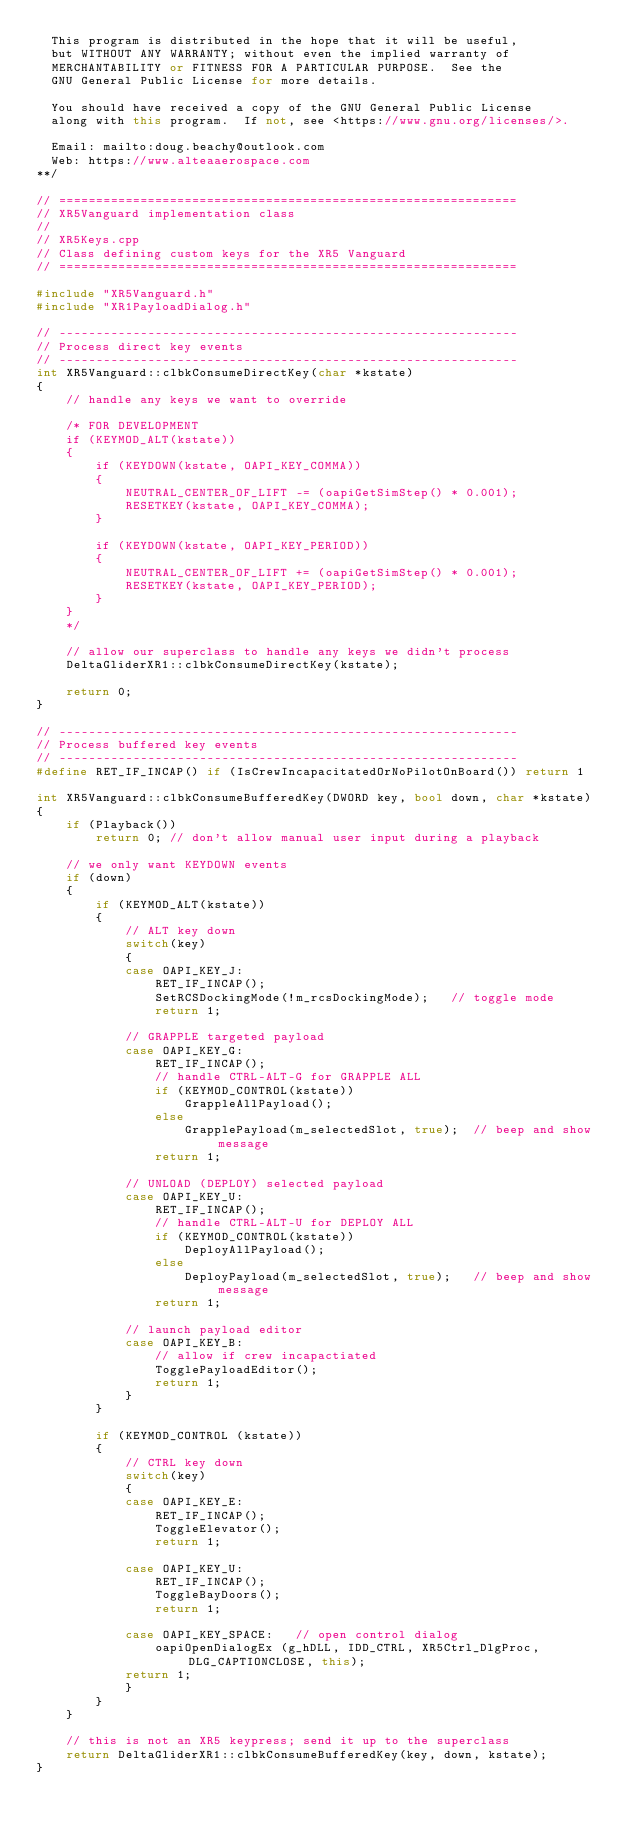Convert code to text. <code><loc_0><loc_0><loc_500><loc_500><_C++_>  This program is distributed in the hope that it will be useful,
  but WITHOUT ANY WARRANTY; without even the implied warranty of
  MERCHANTABILITY or FITNESS FOR A PARTICULAR PURPOSE.  See the
  GNU General Public License for more details.

  You should have received a copy of the GNU General Public License
  along with this program.  If not, see <https://www.gnu.org/licenses/>.

  Email: mailto:doug.beachy@outlook.com
  Web: https://www.alteaaerospace.com
**/

// ==============================================================
// XR5Vanguard implementation class
//
// XR5Keys.cpp
// Class defining custom keys for the XR5 Vanguard
// ==============================================================

#include "XR5Vanguard.h"
#include "XR1PayloadDialog.h"

// --------------------------------------------------------------
// Process direct key events
// --------------------------------------------------------------
int XR5Vanguard::clbkConsumeDirectKey(char *kstate)
{
    // handle any keys we want to override

    /* FOR DEVELOPMENT 
    if (KEYMOD_ALT(kstate))
    {
        if (KEYDOWN(kstate, OAPI_KEY_COMMA)) 
        { 
            NEUTRAL_CENTER_OF_LIFT -= (oapiGetSimStep() * 0.001);
            RESETKEY(kstate, OAPI_KEY_COMMA);
        }

        if (KEYDOWN(kstate, OAPI_KEY_PERIOD)) 
        { 
            NEUTRAL_CENTER_OF_LIFT += (oapiGetSimStep() * 0.001); 
            RESETKEY(kstate, OAPI_KEY_PERIOD);
        }
    }
    */

    // allow our superclass to handle any keys we didn't process
    DeltaGliderXR1::clbkConsumeDirectKey(kstate);

    return 0;
}

// --------------------------------------------------------------
// Process buffered key events
// --------------------------------------------------------------
#define RET_IF_INCAP() if (IsCrewIncapacitatedOrNoPilotOnBoard()) return 1

int XR5Vanguard::clbkConsumeBufferedKey(DWORD key, bool down, char *kstate)
{
    if (Playback()) 
        return 0; // don't allow manual user input during a playback

    // we only want KEYDOWN events
    if (down)
    {
        if (KEYMOD_ALT(kstate)) 
        {
            // ALT key down
            switch(key)
            {
            case OAPI_KEY_J: 
                RET_IF_INCAP();
                SetRCSDockingMode(!m_rcsDockingMode);   // toggle mode
                return 1;

            // GRAPPLE targeted payload
            case OAPI_KEY_G:
                RET_IF_INCAP();
                // handle CTRL-ALT-G for GRAPPLE ALL
                if (KEYMOD_CONTROL(kstate))
                    GrappleAllPayload();
                else
                    GrapplePayload(m_selectedSlot, true);  // beep and show message
                return 1;

            // UNLOAD (DEPLOY) selected payload
            case OAPI_KEY_U:
                RET_IF_INCAP();
                // handle CTRL-ALT-U for DEPLOY ALL
                if (KEYMOD_CONTROL(kstate))
                    DeployAllPayload();
                else
                    DeployPayload(m_selectedSlot, true);   // beep and show message
                return 1;

            // launch payload editor
            case OAPI_KEY_B: 
                // allow if crew incapactiated
                TogglePayloadEditor();
                return 1;
            }
        }

        if (KEYMOD_CONTROL (kstate)) 
        {
            // CTRL key down
            switch(key)
            {
            case OAPI_KEY_E: 
                RET_IF_INCAP();
                ToggleElevator(); 
                return 1;

            case OAPI_KEY_U: 
                RET_IF_INCAP();
                ToggleBayDoors(); 
                return 1;

            case OAPI_KEY_SPACE:   // open control dialog
                oapiOpenDialogEx (g_hDLL, IDD_CTRL, XR5Ctrl_DlgProc, DLG_CAPTIONCLOSE, this);
            return 1;
            }
        }
    }

    // this is not an XR5 keypress; send it up to the superclass
    return DeltaGliderXR1::clbkConsumeBufferedKey(key, down, kstate);
}
</code> 